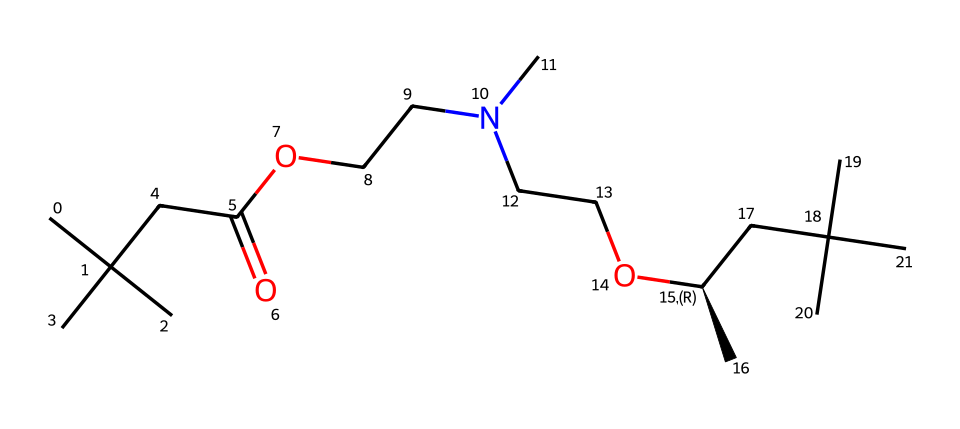What is the functional group present in this compound? The structure contains a carboxyl group, indicated by the –COOH segment, which is characterized by the presence of a carbon atom double-bonded to an oxygen atom and single-bonded to a hydroxyl group.
Answer: carboxyl How many carbon atoms are in the structure? By counting the carbon atoms represented in the structure, there are 15 carbon atoms present in total.
Answer: 15 What type of polymer is formed by the polymerization of this compound? This compound contains both ester and amine linkages, typical in the formation of polyurethanes, which are commonly used in synthetic leather production.
Answer: polyurethane Which element is most abundant in this chemical structure? By tallying the atoms, carbon is the most abundant element, as it is more frequently represented than oxygen or nitrogen throughout the structure.
Answer: carbon What is the role of the nitrogen atom in this polymer? The nitrogen atom is typically involved in forming the amine linkage, which connects the polymer chains and impacts the overall flexibility and strength of the synthetic leather.
Answer: amine linkage 